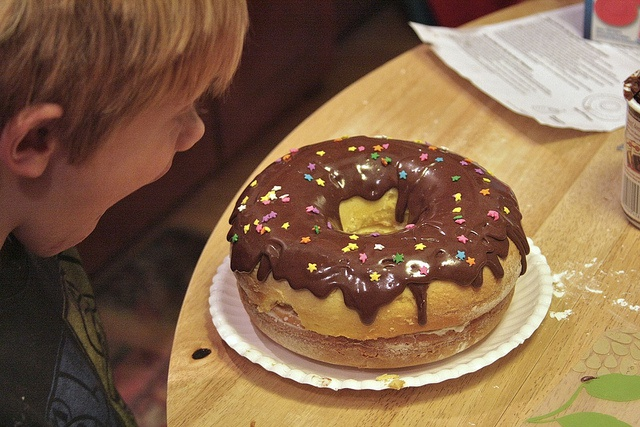Describe the objects in this image and their specific colors. I can see dining table in tan, maroon, and lightgray tones, people in maroon, black, and brown tones, and donut in tan, maroon, brown, and gray tones in this image. 